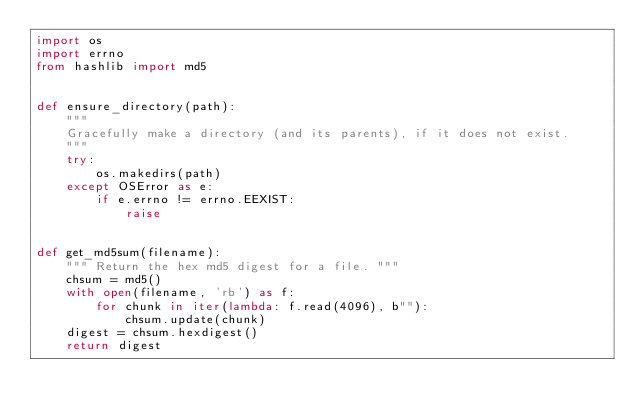<code> <loc_0><loc_0><loc_500><loc_500><_Python_>import os
import errno
from hashlib import md5


def ensure_directory(path):
    """
    Gracefully make a directory (and its parents), if it does not exist.
    """
    try:
        os.makedirs(path)
    except OSError as e:
        if e.errno != errno.EEXIST:
            raise


def get_md5sum(filename):
    """ Return the hex md5 digest for a file. """
    chsum = md5()
    with open(filename, 'rb') as f:
        for chunk in iter(lambda: f.read(4096), b""):
            chsum.update(chunk)
    digest = chsum.hexdigest()
    return digest
</code> 